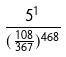<formula> <loc_0><loc_0><loc_500><loc_500>\frac { 5 ^ { 1 } } { ( \frac { 1 0 8 } { 3 6 7 } ) ^ { 4 6 8 } }</formula> 